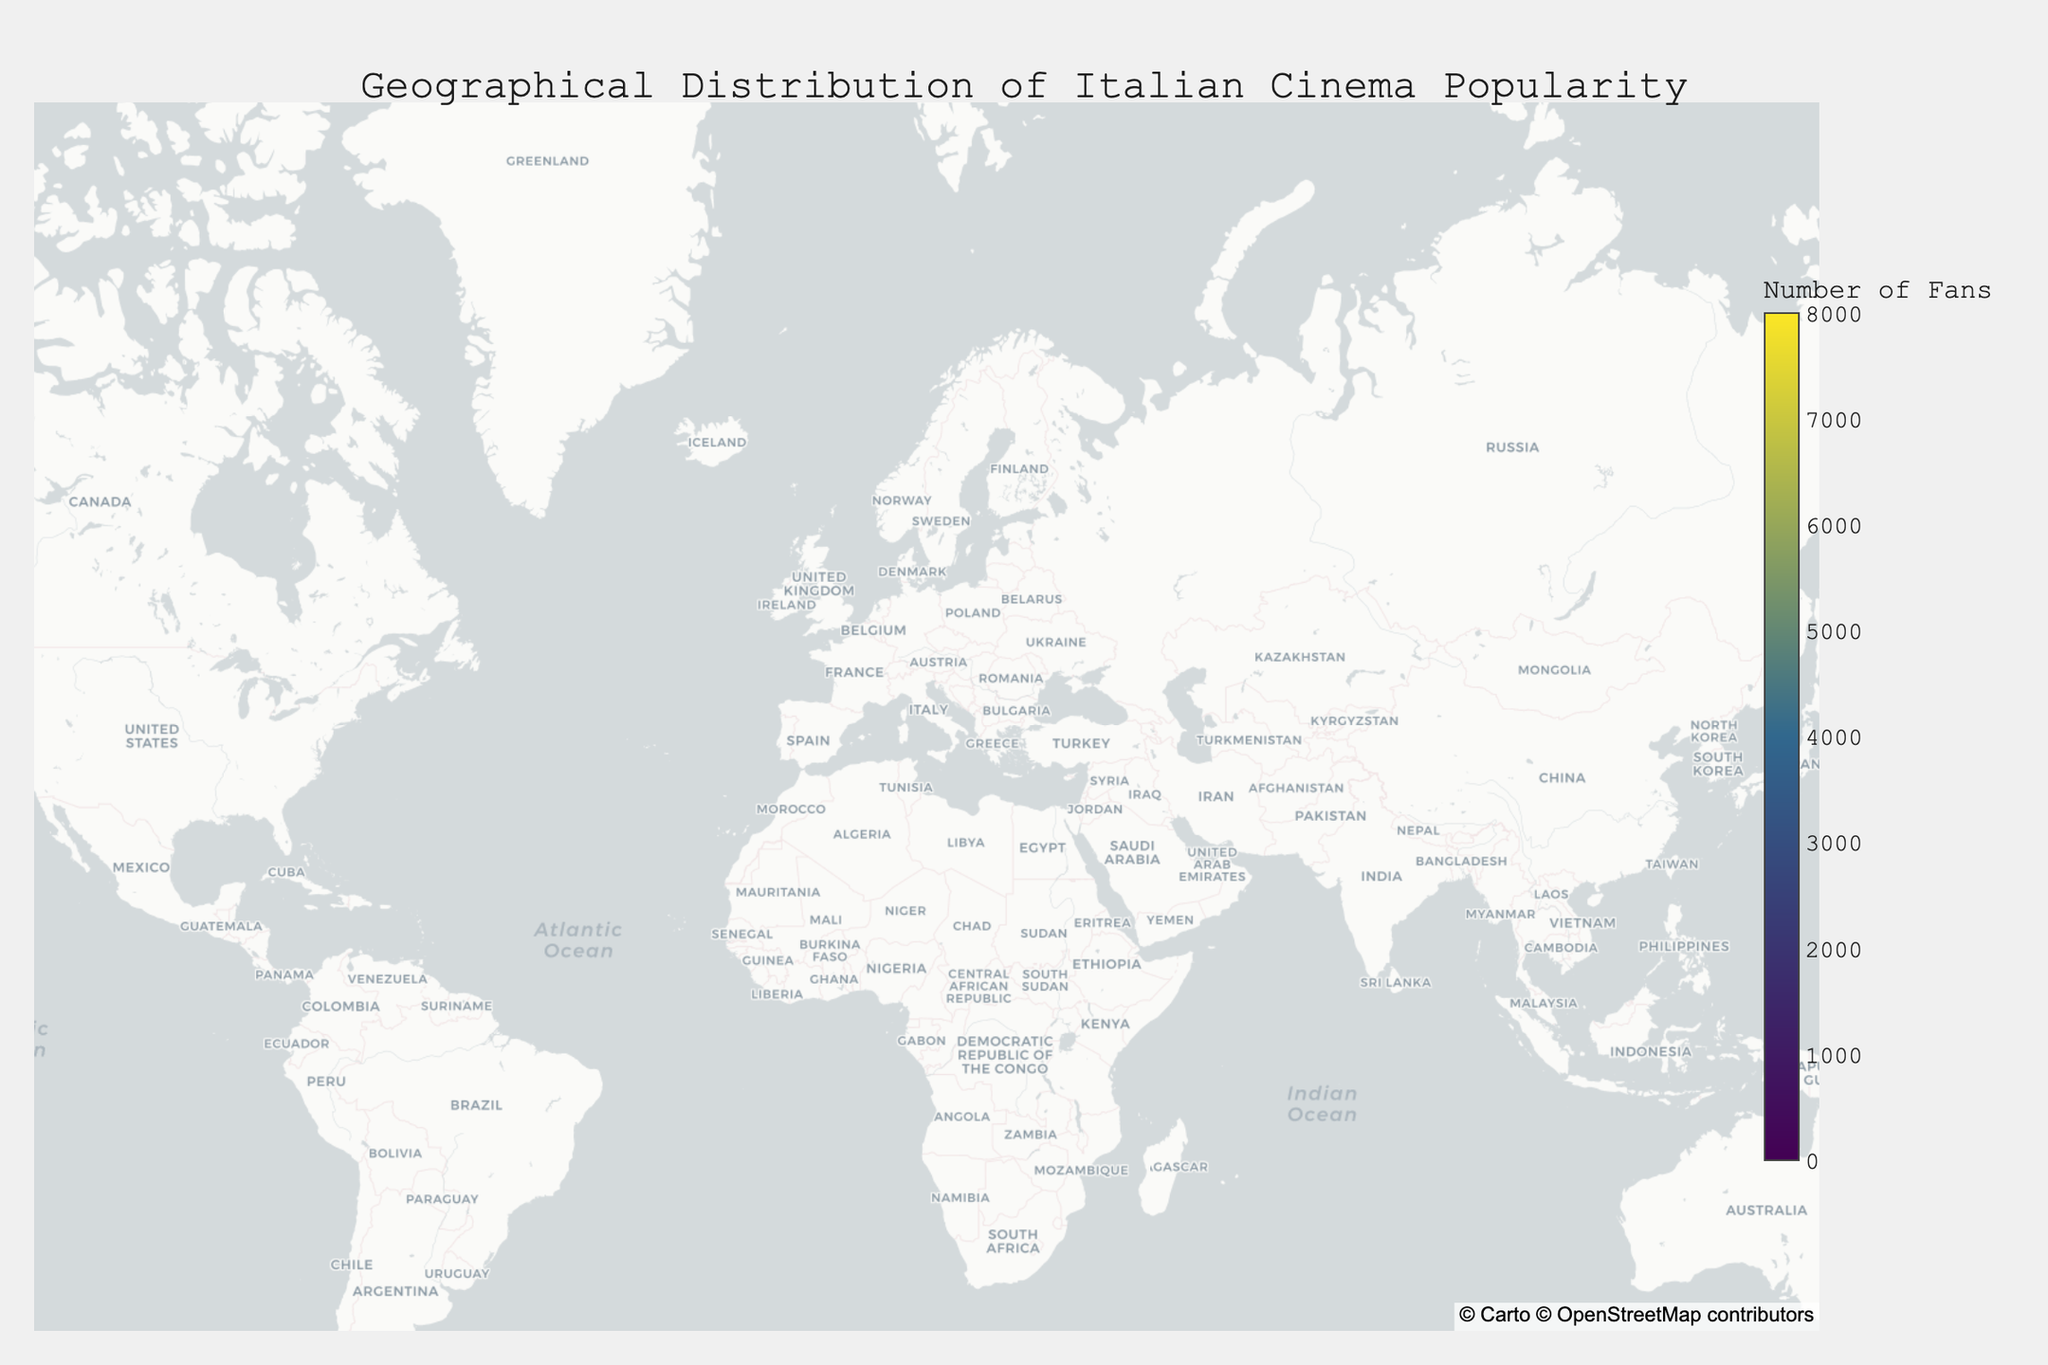What is the title of the plot? The title of the plot is placed at the top center, formatted in a larger font size for prominence. It reads "Geographical Distribution of Italian Cinema Popularity," which directly describes what the plot illustrates.
Answer: Geographical Distribution of Italian Cinema Popularity Which city has the highest number of fans? By observing the density plot and hover text data, you notice that Rome in Lazio, Italy, has the highest number of fans, with a count of 8000. This indicates a strong Italian cinema following in that region.
Answer: Rome How many fans are there in Paris? Locating Paris on the density plot and referring to the hover text data, it is noted that Paris in Ile-de-France, France, has 4000 fans.
Answer: 4000 How does the number of fans in Milan compare with that in London? The plot reveals that Milan, Italy, has 4500 fans while London, United Kingdom, has 5000 fans. By comparison, London has 500 more fans than Milan.
Answer: London has 500 more fans than Milan What is the average number of fans in the Italian cities shown on the plot? Summing the fans from all Italian cities: 500 (Aosta) + 2500 (Turin) + 4500 (Milan) + 2800 (Venice) + 3200 (Bologna) + 3700 (Florence) + 8000 (Rome) + 4200 (Naples) + 2100 (Bari) + 3500 (Palermo) + 1600 (Cagliari) = 39600. There are 11 cities, thus the average is 39600 / 11 = 3600.
Answer: 3600 Which region outside Italy has the highest number of fans? Outside of Italy, referring to the hover text data, Los Angeles in California, USA, has the highest number of fans, which amounts to 6000.
Answer: Los Angeles Is the number of fans higher in the United States or in Germany? Summing the fans from both cities in the United States: 6000 (Los Angeles) + 5500 (New York City) = 11500. The number of fans in Berlin, Germany is 3000. Comparing these sums shows the United States has more fans.
Answer: The United States How does Tokyo compare to Sydney in terms of the number of fans? Tokyo, Japan has 2000 fans, whereas Sydney, Australia has 1800 fans, making Tokyo's count 200 higher than Sydney's.
Answer: Tokyo has 200 more fans than Sydney Which city has the least number of fans? By examining the density plot for minimal hover text data, it is observed that Aosta in the Aosta Valley, Italy, has the least number of fans, with just 500 fans.
Answer: Aosta 